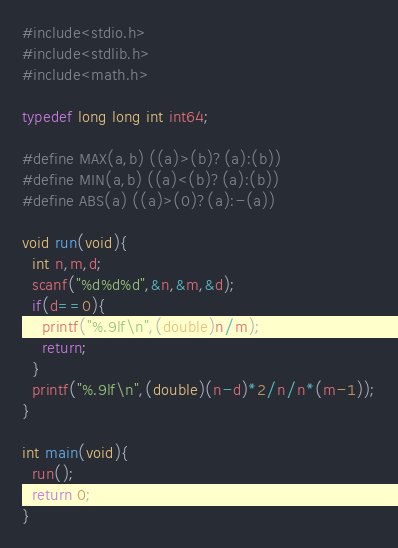Convert code to text. <code><loc_0><loc_0><loc_500><loc_500><_C_>#include<stdio.h>
#include<stdlib.h>
#include<math.h>

typedef long long int int64;

#define MAX(a,b) ((a)>(b)?(a):(b))
#define MIN(a,b) ((a)<(b)?(a):(b))
#define ABS(a) ((a)>(0)?(a):-(a))

void run(void){
  int n,m,d;
  scanf("%d%d%d",&n,&m,&d);
  if(d==0){
    printf("%.9lf\n",(double)n/m);
    return;
  }
  printf("%.9lf\n",(double)(n-d)*2/n/n*(m-1));
}

int main(void){
  run();
  return 0;
}
</code> 